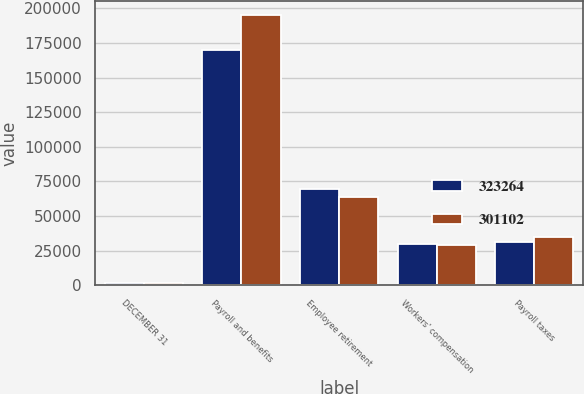Convert chart. <chart><loc_0><loc_0><loc_500><loc_500><stacked_bar_chart><ecel><fcel>DECEMBER 31<fcel>Payroll and benefits<fcel>Employee retirement<fcel>Workers' compensation<fcel>Payroll taxes<nl><fcel>323264<fcel>2008<fcel>170123<fcel>69868<fcel>29630<fcel>31481<nl><fcel>301102<fcel>2007<fcel>195383<fcel>64049<fcel>28996<fcel>34836<nl></chart> 